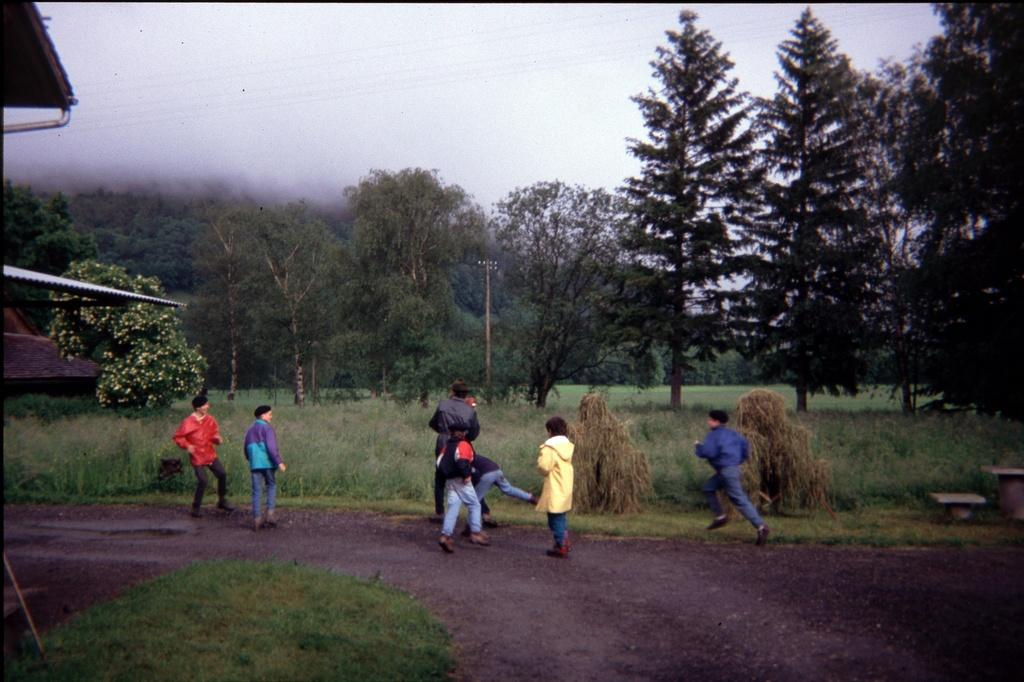What can be seen in the image? There are people standing in the image. What type of ground is visible in the image? There is grass at the bottom of the image. What other natural elements can be seen in the image? There are trees in the image. What is visible in the background of the image? The sky is visible at the top of the image. What type of dinner is being served on the grass in the image? There is no dinner or food present in the image; it only features people standing on grass. Can you see a snake slithering through the grass in the image? There is no snake visible in the image; it only features people standing on grass. 